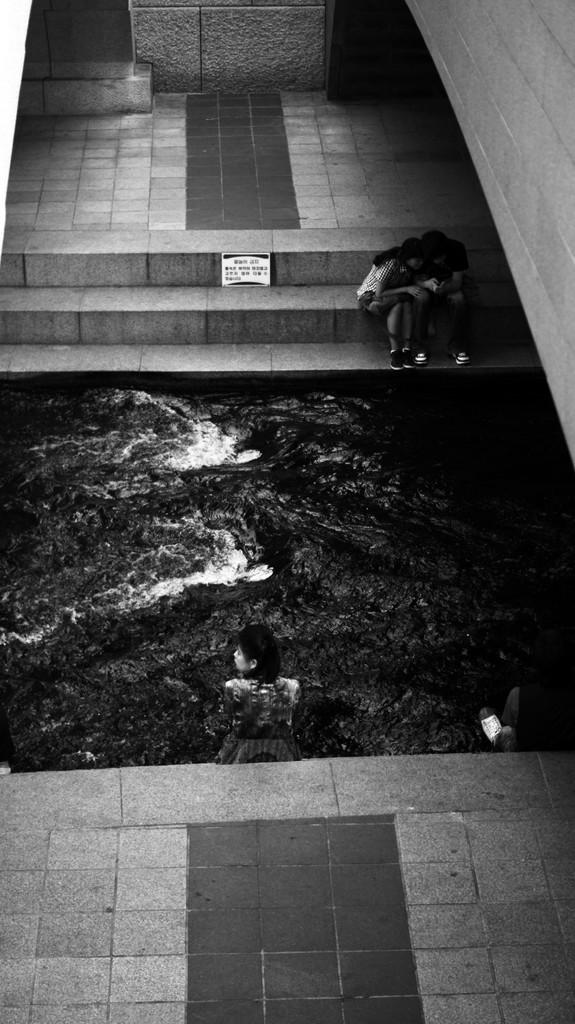What is the color scheme of the image? The image is black and white. What activity are the people engaged in? People are swimming in the water. Can you describe the position of the two people mentioned? Two people are sitting on the stairs. What is located at the right side of the image? There is a wall at the right side of the image. How many zebras can be seen grazing near the wall in the image? There are no zebras present in the image; it features people swimming and sitting on stairs. What trick is being performed by the people in the water? There is no trick being performed by the people in the water; they are simply swimming. 